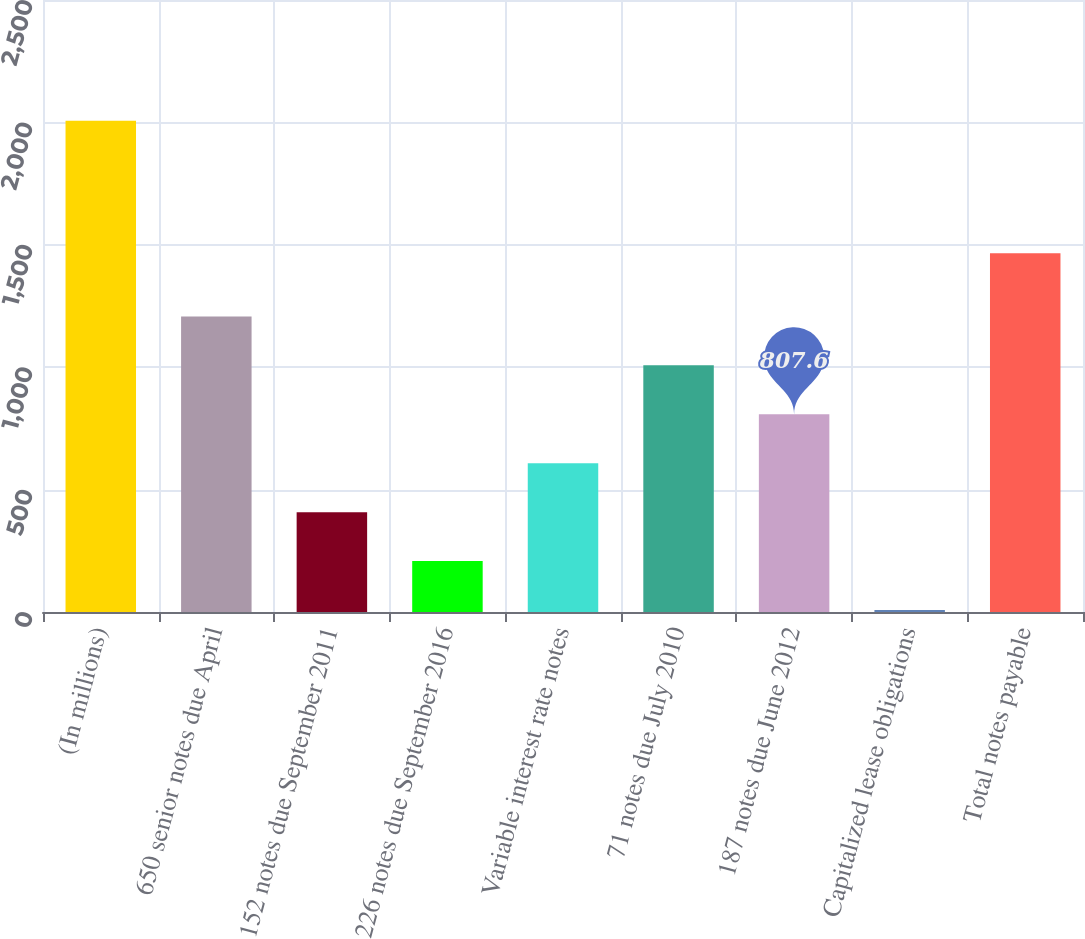<chart> <loc_0><loc_0><loc_500><loc_500><bar_chart><fcel>(In millions)<fcel>650 senior notes due April<fcel>152 notes due September 2011<fcel>226 notes due September 2016<fcel>Variable interest rate notes<fcel>71 notes due July 2010<fcel>187 notes due June 2012<fcel>Capitalized lease obligations<fcel>Total notes payable<nl><fcel>2007<fcel>1207.4<fcel>407.8<fcel>207.9<fcel>607.7<fcel>1007.5<fcel>807.6<fcel>8<fcel>1465<nl></chart> 